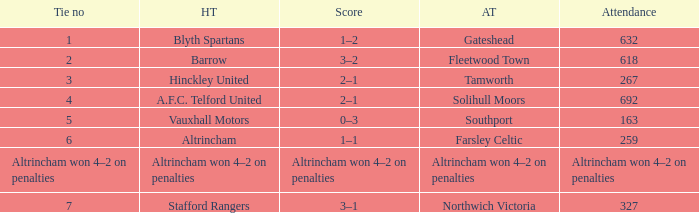What home team had 2 ties? Barrow. 